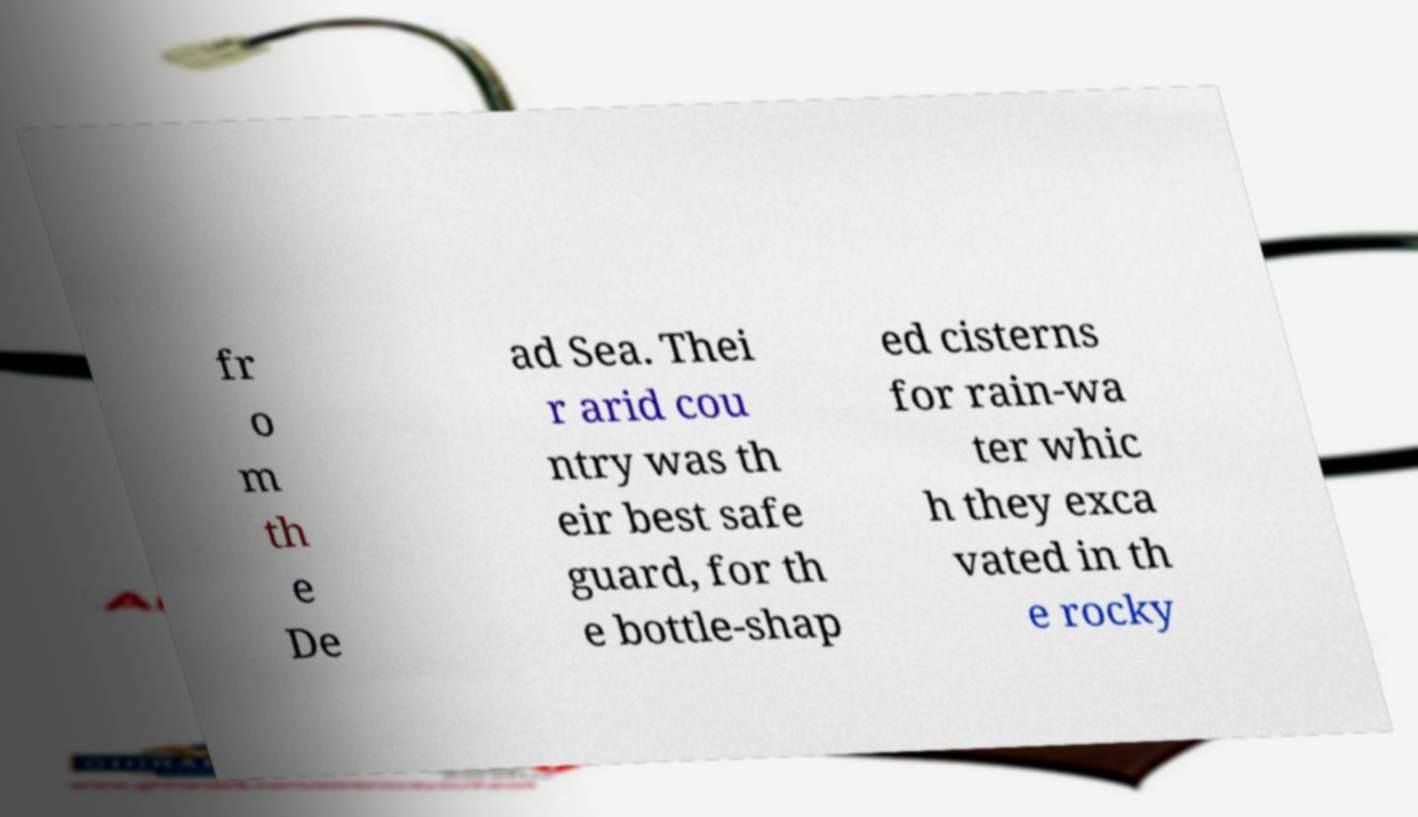Could you assist in decoding the text presented in this image and type it out clearly? fr o m th e De ad Sea. Thei r arid cou ntry was th eir best safe guard, for th e bottle-shap ed cisterns for rain-wa ter whic h they exca vated in th e rocky 